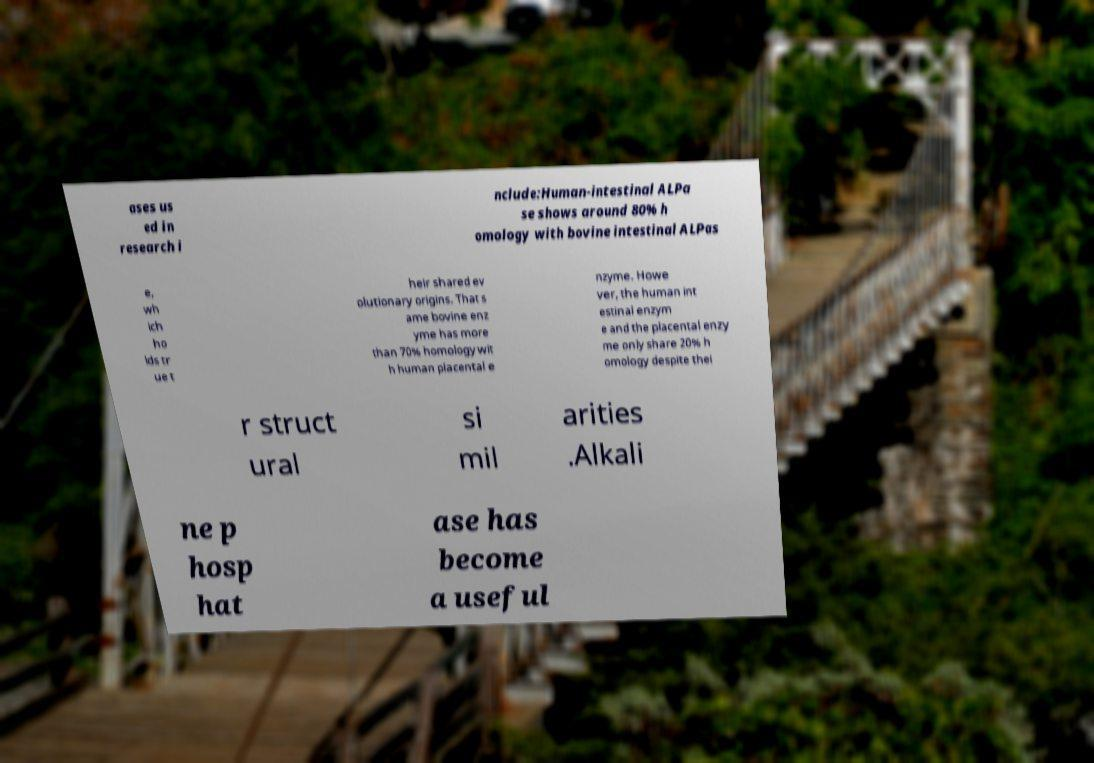There's text embedded in this image that I need extracted. Can you transcribe it verbatim? ases us ed in research i nclude:Human-intestinal ALPa se shows around 80% h omology with bovine intestinal ALPas e, wh ich ho lds tr ue t heir shared ev olutionary origins. That s ame bovine enz yme has more than 70% homology wit h human placental e nzyme. Howe ver, the human int estinal enzym e and the placental enzy me only share 20% h omology despite thei r struct ural si mil arities .Alkali ne p hosp hat ase has become a useful 